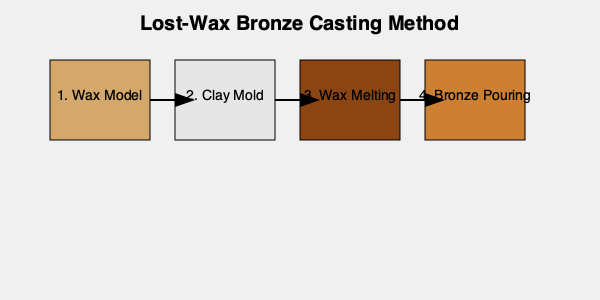What is the correct sequence of steps in the lost-wax bronze casting method as depicted in the image? The lost-wax bronze casting method, also known as cire perdue, is an ancient technique used for creating bronze sculptures. The correct sequence of steps is as follows:

1. Wax Model: The process begins with creating a detailed wax model of the desired sculpture. This model is carefully crafted to include all the intricate details of the final bronze piece.

2. Clay Mold: The wax model is then covered with a heat-resistant material, typically clay, to create a mold. This mold captures all the details of the wax model on its interior surface.

3. Wax Melting: The clay mold, with the wax model inside, is heated. This causes the wax to melt and drain out through small channels, leaving a hollow cavity in the shape of the original model.

4. Bronze Pouring: Molten bronze is then poured into the cavity left by the melted wax. The bronze takes on the exact shape and details of the original wax model.

After the bronze cools and solidifies, the clay mold is broken away, revealing the bronze sculpture. Final steps typically include cleaning, chasing (refining the surface), and patination.

This sequence ensures that the final bronze sculpture is an exact replica of the original wax model, preserving all its intricate details.
Answer: 1-2-3-4 